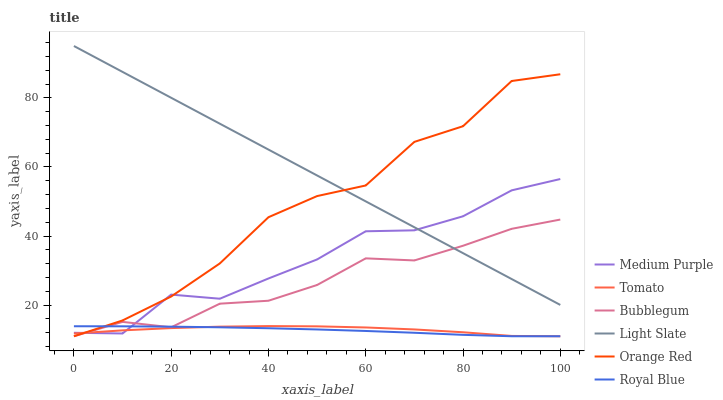Does Bubblegum have the minimum area under the curve?
Answer yes or no. No. Does Bubblegum have the maximum area under the curve?
Answer yes or no. No. Is Bubblegum the smoothest?
Answer yes or no. No. Is Bubblegum the roughest?
Answer yes or no. No. Does Light Slate have the lowest value?
Answer yes or no. No. Does Bubblegum have the highest value?
Answer yes or no. No. Is Royal Blue less than Light Slate?
Answer yes or no. Yes. Is Light Slate greater than Royal Blue?
Answer yes or no. Yes. Does Royal Blue intersect Light Slate?
Answer yes or no. No. 